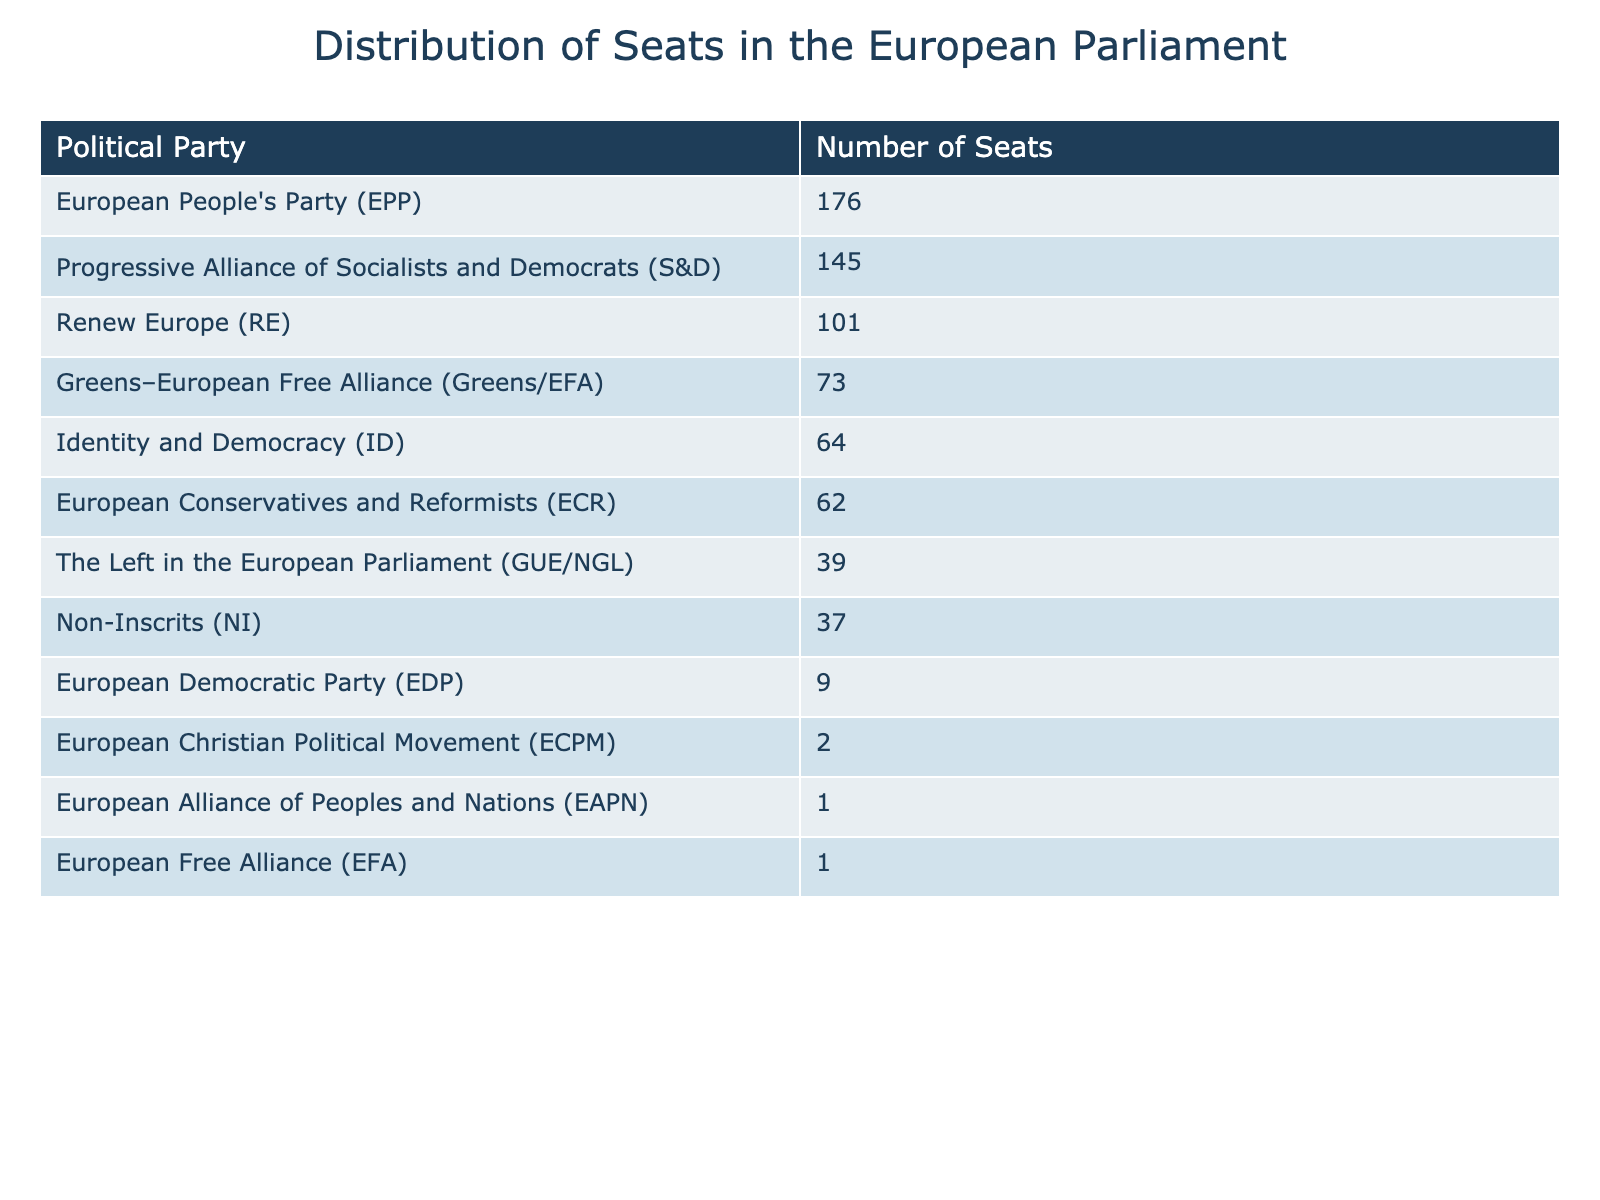What is the total number of seats in the European Parliament based on this table? To find the total number of seats, we need to sum all the seats from each political party listed in the table. Adding them up gives us: 176 + 145 + 101 + 73 + 64 + 62 + 39 + 37 + 9 + 2 + 1 + 1 = 709.
Answer: 709 Which political party has the highest number of seats? By looking at the table, we can see that the European People's Party (EPP) has the highest number of seats at 176.
Answer: European People's Party (EPP) How many more seats does the Progressive Alliance of Socialists and Democrats (S&D) have than the European Conservatives and Reformists (ECR)? To find this, we subtract the number of seats held by ECR from S&D: 145 (S&D) - 62 (ECR) = 83.
Answer: 83 What is the combined total of seats for the Greens–European Free Alliance (Greens/EFA) and The Left in the European Parliament (GUE/NGL)? We add the number of seats these two parties have: 73 (Greens/EFA) + 39 (GUE/NGL) = 112.
Answer: 112 Is it true that the Non-Inscrits (NI) have more seats than the European Democratic Party (EDP)? To answer this, we need to compare their seat counts: Non-Inscrits have 37 seats, while the European Democratic Party has 9 seats. Since 37 is greater than 9, the statement is true.
Answer: Yes What percentage of the total seats does the Identity and Democracy (ID) party hold? First, we determine ID’s seats: 64. Then we calculate the percentage: (64 / 709) * 100 ≈ 9.02%.
Answer: Approximately 9.02% If the European Christian Political Movement (ECPM) were to gain 3 additional seats, what would their new total be? Adding 3 to the current seats held by ECPM (which is 2) gives us 2 + 3 = 5.
Answer: 5 Which political party has the lowest number of seats, and how many do they have? By examining the table, we see that both the European Alliance of Peoples and Nations (EAPN) and the European Free Alliance (EFA) each have 1 seat, which is the lowest.
Answer: European Alliance of Peoples and Nations (EAPN) and European Free Alliance (EFA) with 1 seat each What is the difference in number of seats between the party with the most seats and the one with the least? The party with the most seats is EPP (176 seats), and the one with the least are EAPN and EFA (1 seat each). The difference is calculated as 176 - 1 = 175.
Answer: 175 How many parties have more than 100 seats? We identify the parties with more than 100 seats from the table: EPP (176), S&D (145), and RE (101). This makes a total of 3 parties.
Answer: 3 